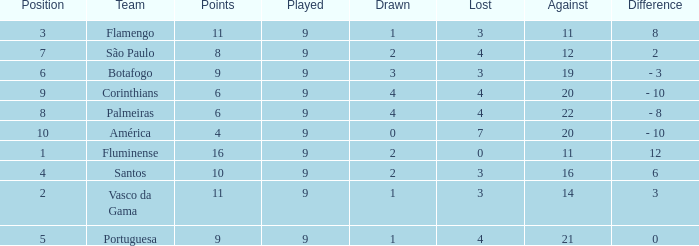Which average Played has a Drawn smaller than 1, and Points larger than 4? None. 